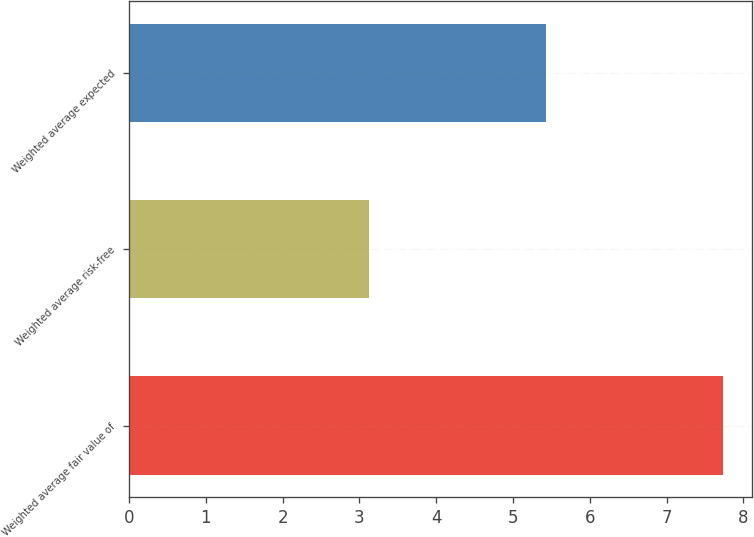<chart> <loc_0><loc_0><loc_500><loc_500><bar_chart><fcel>Weighted average fair value of<fcel>Weighted average risk-free<fcel>Weighted average expected<nl><fcel>7.73<fcel>3.13<fcel>5.43<nl></chart> 